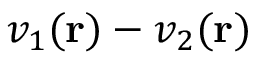<formula> <loc_0><loc_0><loc_500><loc_500>v _ { 1 } ( r ) - v _ { 2 } ( r )</formula> 